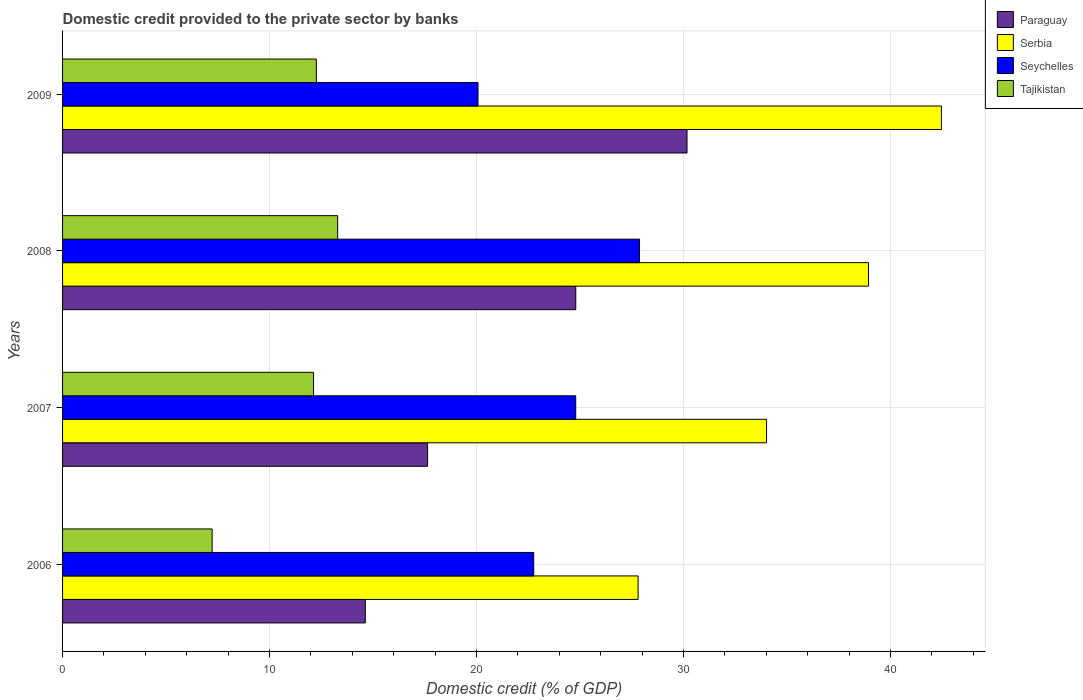How many different coloured bars are there?
Provide a succinct answer. 4. Are the number of bars per tick equal to the number of legend labels?
Give a very brief answer. Yes. How many bars are there on the 2nd tick from the bottom?
Provide a short and direct response. 4. In how many cases, is the number of bars for a given year not equal to the number of legend labels?
Keep it short and to the point. 0. What is the domestic credit provided to the private sector by banks in Tajikistan in 2009?
Keep it short and to the point. 12.26. Across all years, what is the maximum domestic credit provided to the private sector by banks in Serbia?
Your response must be concise. 42.46. Across all years, what is the minimum domestic credit provided to the private sector by banks in Seychelles?
Provide a short and direct response. 20.07. In which year was the domestic credit provided to the private sector by banks in Serbia minimum?
Keep it short and to the point. 2006. What is the total domestic credit provided to the private sector by banks in Serbia in the graph?
Your response must be concise. 143.23. What is the difference between the domestic credit provided to the private sector by banks in Serbia in 2008 and that in 2009?
Offer a very short reply. -3.52. What is the difference between the domestic credit provided to the private sector by banks in Paraguay in 2009 and the domestic credit provided to the private sector by banks in Seychelles in 2007?
Offer a very short reply. 5.38. What is the average domestic credit provided to the private sector by banks in Serbia per year?
Your response must be concise. 35.81. In the year 2008, what is the difference between the domestic credit provided to the private sector by banks in Seychelles and domestic credit provided to the private sector by banks in Serbia?
Provide a short and direct response. -11.06. What is the ratio of the domestic credit provided to the private sector by banks in Tajikistan in 2006 to that in 2009?
Your response must be concise. 0.59. Is the domestic credit provided to the private sector by banks in Serbia in 2007 less than that in 2008?
Offer a very short reply. Yes. Is the difference between the domestic credit provided to the private sector by banks in Seychelles in 2006 and 2008 greater than the difference between the domestic credit provided to the private sector by banks in Serbia in 2006 and 2008?
Your answer should be compact. Yes. What is the difference between the highest and the second highest domestic credit provided to the private sector by banks in Tajikistan?
Your answer should be very brief. 1.03. What is the difference between the highest and the lowest domestic credit provided to the private sector by banks in Paraguay?
Make the answer very short. 15.54. In how many years, is the domestic credit provided to the private sector by banks in Tajikistan greater than the average domestic credit provided to the private sector by banks in Tajikistan taken over all years?
Provide a succinct answer. 3. What does the 1st bar from the top in 2008 represents?
Your answer should be compact. Tajikistan. What does the 1st bar from the bottom in 2006 represents?
Provide a short and direct response. Paraguay. How many bars are there?
Give a very brief answer. 16. How many years are there in the graph?
Provide a succinct answer. 4. Does the graph contain any zero values?
Provide a short and direct response. No. Does the graph contain grids?
Provide a short and direct response. Yes. Where does the legend appear in the graph?
Offer a terse response. Top right. How many legend labels are there?
Provide a succinct answer. 4. How are the legend labels stacked?
Your response must be concise. Vertical. What is the title of the graph?
Your answer should be compact. Domestic credit provided to the private sector by banks. What is the label or title of the X-axis?
Provide a succinct answer. Domestic credit (% of GDP). What is the Domestic credit (% of GDP) in Paraguay in 2006?
Offer a terse response. 14.63. What is the Domestic credit (% of GDP) in Serbia in 2006?
Keep it short and to the point. 27.81. What is the Domestic credit (% of GDP) in Seychelles in 2006?
Offer a very short reply. 22.76. What is the Domestic credit (% of GDP) of Tajikistan in 2006?
Provide a succinct answer. 7.23. What is the Domestic credit (% of GDP) of Paraguay in 2007?
Your answer should be compact. 17.64. What is the Domestic credit (% of GDP) of Serbia in 2007?
Offer a very short reply. 34.01. What is the Domestic credit (% of GDP) in Seychelles in 2007?
Ensure brevity in your answer.  24.79. What is the Domestic credit (% of GDP) in Tajikistan in 2007?
Give a very brief answer. 12.13. What is the Domestic credit (% of GDP) in Paraguay in 2008?
Your answer should be compact. 24.8. What is the Domestic credit (% of GDP) in Serbia in 2008?
Offer a very short reply. 38.94. What is the Domestic credit (% of GDP) in Seychelles in 2008?
Offer a very short reply. 27.88. What is the Domestic credit (% of GDP) of Tajikistan in 2008?
Your answer should be very brief. 13.29. What is the Domestic credit (% of GDP) in Paraguay in 2009?
Ensure brevity in your answer.  30.17. What is the Domestic credit (% of GDP) in Serbia in 2009?
Offer a very short reply. 42.46. What is the Domestic credit (% of GDP) in Seychelles in 2009?
Your answer should be very brief. 20.07. What is the Domestic credit (% of GDP) of Tajikistan in 2009?
Offer a terse response. 12.26. Across all years, what is the maximum Domestic credit (% of GDP) in Paraguay?
Offer a very short reply. 30.17. Across all years, what is the maximum Domestic credit (% of GDP) of Serbia?
Your response must be concise. 42.46. Across all years, what is the maximum Domestic credit (% of GDP) in Seychelles?
Ensure brevity in your answer.  27.88. Across all years, what is the maximum Domestic credit (% of GDP) of Tajikistan?
Offer a terse response. 13.29. Across all years, what is the minimum Domestic credit (% of GDP) in Paraguay?
Make the answer very short. 14.63. Across all years, what is the minimum Domestic credit (% of GDP) in Serbia?
Provide a succinct answer. 27.81. Across all years, what is the minimum Domestic credit (% of GDP) of Seychelles?
Your response must be concise. 20.07. Across all years, what is the minimum Domestic credit (% of GDP) in Tajikistan?
Offer a terse response. 7.23. What is the total Domestic credit (% of GDP) in Paraguay in the graph?
Provide a short and direct response. 87.23. What is the total Domestic credit (% of GDP) of Serbia in the graph?
Give a very brief answer. 143.23. What is the total Domestic credit (% of GDP) in Seychelles in the graph?
Make the answer very short. 95.51. What is the total Domestic credit (% of GDP) of Tajikistan in the graph?
Ensure brevity in your answer.  44.91. What is the difference between the Domestic credit (% of GDP) of Paraguay in 2006 and that in 2007?
Make the answer very short. -3.01. What is the difference between the Domestic credit (% of GDP) in Serbia in 2006 and that in 2007?
Offer a very short reply. -6.21. What is the difference between the Domestic credit (% of GDP) of Seychelles in 2006 and that in 2007?
Your answer should be compact. -2.03. What is the difference between the Domestic credit (% of GDP) in Tajikistan in 2006 and that in 2007?
Your answer should be very brief. -4.9. What is the difference between the Domestic credit (% of GDP) in Paraguay in 2006 and that in 2008?
Ensure brevity in your answer.  -10.17. What is the difference between the Domestic credit (% of GDP) in Serbia in 2006 and that in 2008?
Your response must be concise. -11.13. What is the difference between the Domestic credit (% of GDP) in Seychelles in 2006 and that in 2008?
Make the answer very short. -5.11. What is the difference between the Domestic credit (% of GDP) in Tajikistan in 2006 and that in 2008?
Make the answer very short. -6.07. What is the difference between the Domestic credit (% of GDP) in Paraguay in 2006 and that in 2009?
Your answer should be very brief. -15.54. What is the difference between the Domestic credit (% of GDP) of Serbia in 2006 and that in 2009?
Provide a short and direct response. -14.66. What is the difference between the Domestic credit (% of GDP) in Seychelles in 2006 and that in 2009?
Make the answer very short. 2.69. What is the difference between the Domestic credit (% of GDP) of Tajikistan in 2006 and that in 2009?
Ensure brevity in your answer.  -5.04. What is the difference between the Domestic credit (% of GDP) of Paraguay in 2007 and that in 2008?
Offer a very short reply. -7.16. What is the difference between the Domestic credit (% of GDP) in Serbia in 2007 and that in 2008?
Provide a short and direct response. -4.93. What is the difference between the Domestic credit (% of GDP) in Seychelles in 2007 and that in 2008?
Give a very brief answer. -3.08. What is the difference between the Domestic credit (% of GDP) in Tajikistan in 2007 and that in 2008?
Your answer should be compact. -1.17. What is the difference between the Domestic credit (% of GDP) in Paraguay in 2007 and that in 2009?
Your answer should be very brief. -12.54. What is the difference between the Domestic credit (% of GDP) in Serbia in 2007 and that in 2009?
Your response must be concise. -8.45. What is the difference between the Domestic credit (% of GDP) in Seychelles in 2007 and that in 2009?
Provide a short and direct response. 4.72. What is the difference between the Domestic credit (% of GDP) of Tajikistan in 2007 and that in 2009?
Offer a very short reply. -0.14. What is the difference between the Domestic credit (% of GDP) of Paraguay in 2008 and that in 2009?
Keep it short and to the point. -5.38. What is the difference between the Domestic credit (% of GDP) in Serbia in 2008 and that in 2009?
Keep it short and to the point. -3.52. What is the difference between the Domestic credit (% of GDP) in Seychelles in 2008 and that in 2009?
Your answer should be very brief. 7.8. What is the difference between the Domestic credit (% of GDP) of Tajikistan in 2008 and that in 2009?
Your answer should be compact. 1.03. What is the difference between the Domestic credit (% of GDP) in Paraguay in 2006 and the Domestic credit (% of GDP) in Serbia in 2007?
Your answer should be compact. -19.39. What is the difference between the Domestic credit (% of GDP) in Paraguay in 2006 and the Domestic credit (% of GDP) in Seychelles in 2007?
Your response must be concise. -10.17. What is the difference between the Domestic credit (% of GDP) in Paraguay in 2006 and the Domestic credit (% of GDP) in Tajikistan in 2007?
Give a very brief answer. 2.5. What is the difference between the Domestic credit (% of GDP) of Serbia in 2006 and the Domestic credit (% of GDP) of Seychelles in 2007?
Provide a succinct answer. 3.01. What is the difference between the Domestic credit (% of GDP) of Serbia in 2006 and the Domestic credit (% of GDP) of Tajikistan in 2007?
Offer a very short reply. 15.68. What is the difference between the Domestic credit (% of GDP) in Seychelles in 2006 and the Domestic credit (% of GDP) in Tajikistan in 2007?
Give a very brief answer. 10.64. What is the difference between the Domestic credit (% of GDP) in Paraguay in 2006 and the Domestic credit (% of GDP) in Serbia in 2008?
Ensure brevity in your answer.  -24.31. What is the difference between the Domestic credit (% of GDP) of Paraguay in 2006 and the Domestic credit (% of GDP) of Seychelles in 2008?
Offer a very short reply. -13.25. What is the difference between the Domestic credit (% of GDP) of Paraguay in 2006 and the Domestic credit (% of GDP) of Tajikistan in 2008?
Offer a very short reply. 1.33. What is the difference between the Domestic credit (% of GDP) in Serbia in 2006 and the Domestic credit (% of GDP) in Seychelles in 2008?
Ensure brevity in your answer.  -0.07. What is the difference between the Domestic credit (% of GDP) of Serbia in 2006 and the Domestic credit (% of GDP) of Tajikistan in 2008?
Keep it short and to the point. 14.52. What is the difference between the Domestic credit (% of GDP) of Seychelles in 2006 and the Domestic credit (% of GDP) of Tajikistan in 2008?
Offer a terse response. 9.47. What is the difference between the Domestic credit (% of GDP) in Paraguay in 2006 and the Domestic credit (% of GDP) in Serbia in 2009?
Offer a terse response. -27.84. What is the difference between the Domestic credit (% of GDP) in Paraguay in 2006 and the Domestic credit (% of GDP) in Seychelles in 2009?
Give a very brief answer. -5.45. What is the difference between the Domestic credit (% of GDP) of Paraguay in 2006 and the Domestic credit (% of GDP) of Tajikistan in 2009?
Keep it short and to the point. 2.36. What is the difference between the Domestic credit (% of GDP) of Serbia in 2006 and the Domestic credit (% of GDP) of Seychelles in 2009?
Offer a terse response. 7.73. What is the difference between the Domestic credit (% of GDP) in Serbia in 2006 and the Domestic credit (% of GDP) in Tajikistan in 2009?
Your response must be concise. 15.55. What is the difference between the Domestic credit (% of GDP) in Seychelles in 2006 and the Domestic credit (% of GDP) in Tajikistan in 2009?
Ensure brevity in your answer.  10.5. What is the difference between the Domestic credit (% of GDP) of Paraguay in 2007 and the Domestic credit (% of GDP) of Serbia in 2008?
Provide a succinct answer. -21.3. What is the difference between the Domestic credit (% of GDP) in Paraguay in 2007 and the Domestic credit (% of GDP) in Seychelles in 2008?
Your response must be concise. -10.24. What is the difference between the Domestic credit (% of GDP) in Paraguay in 2007 and the Domestic credit (% of GDP) in Tajikistan in 2008?
Offer a terse response. 4.34. What is the difference between the Domestic credit (% of GDP) in Serbia in 2007 and the Domestic credit (% of GDP) in Seychelles in 2008?
Give a very brief answer. 6.14. What is the difference between the Domestic credit (% of GDP) in Serbia in 2007 and the Domestic credit (% of GDP) in Tajikistan in 2008?
Provide a short and direct response. 20.72. What is the difference between the Domestic credit (% of GDP) in Seychelles in 2007 and the Domestic credit (% of GDP) in Tajikistan in 2008?
Your answer should be compact. 11.5. What is the difference between the Domestic credit (% of GDP) of Paraguay in 2007 and the Domestic credit (% of GDP) of Serbia in 2009?
Provide a succinct answer. -24.83. What is the difference between the Domestic credit (% of GDP) in Paraguay in 2007 and the Domestic credit (% of GDP) in Seychelles in 2009?
Give a very brief answer. -2.44. What is the difference between the Domestic credit (% of GDP) in Paraguay in 2007 and the Domestic credit (% of GDP) in Tajikistan in 2009?
Make the answer very short. 5.37. What is the difference between the Domestic credit (% of GDP) in Serbia in 2007 and the Domestic credit (% of GDP) in Seychelles in 2009?
Your answer should be very brief. 13.94. What is the difference between the Domestic credit (% of GDP) in Serbia in 2007 and the Domestic credit (% of GDP) in Tajikistan in 2009?
Give a very brief answer. 21.75. What is the difference between the Domestic credit (% of GDP) of Seychelles in 2007 and the Domestic credit (% of GDP) of Tajikistan in 2009?
Keep it short and to the point. 12.53. What is the difference between the Domestic credit (% of GDP) of Paraguay in 2008 and the Domestic credit (% of GDP) of Serbia in 2009?
Give a very brief answer. -17.67. What is the difference between the Domestic credit (% of GDP) in Paraguay in 2008 and the Domestic credit (% of GDP) in Seychelles in 2009?
Provide a short and direct response. 4.72. What is the difference between the Domestic credit (% of GDP) of Paraguay in 2008 and the Domestic credit (% of GDP) of Tajikistan in 2009?
Ensure brevity in your answer.  12.53. What is the difference between the Domestic credit (% of GDP) in Serbia in 2008 and the Domestic credit (% of GDP) in Seychelles in 2009?
Provide a succinct answer. 18.87. What is the difference between the Domestic credit (% of GDP) of Serbia in 2008 and the Domestic credit (% of GDP) of Tajikistan in 2009?
Offer a terse response. 26.68. What is the difference between the Domestic credit (% of GDP) in Seychelles in 2008 and the Domestic credit (% of GDP) in Tajikistan in 2009?
Give a very brief answer. 15.61. What is the average Domestic credit (% of GDP) of Paraguay per year?
Keep it short and to the point. 21.81. What is the average Domestic credit (% of GDP) of Serbia per year?
Ensure brevity in your answer.  35.81. What is the average Domestic credit (% of GDP) in Seychelles per year?
Ensure brevity in your answer.  23.88. What is the average Domestic credit (% of GDP) of Tajikistan per year?
Keep it short and to the point. 11.23. In the year 2006, what is the difference between the Domestic credit (% of GDP) in Paraguay and Domestic credit (% of GDP) in Serbia?
Ensure brevity in your answer.  -13.18. In the year 2006, what is the difference between the Domestic credit (% of GDP) of Paraguay and Domestic credit (% of GDP) of Seychelles?
Make the answer very short. -8.14. In the year 2006, what is the difference between the Domestic credit (% of GDP) in Paraguay and Domestic credit (% of GDP) in Tajikistan?
Your response must be concise. 7.4. In the year 2006, what is the difference between the Domestic credit (% of GDP) in Serbia and Domestic credit (% of GDP) in Seychelles?
Your response must be concise. 5.04. In the year 2006, what is the difference between the Domestic credit (% of GDP) of Serbia and Domestic credit (% of GDP) of Tajikistan?
Your answer should be very brief. 20.58. In the year 2006, what is the difference between the Domestic credit (% of GDP) of Seychelles and Domestic credit (% of GDP) of Tajikistan?
Your answer should be very brief. 15.54. In the year 2007, what is the difference between the Domestic credit (% of GDP) of Paraguay and Domestic credit (% of GDP) of Serbia?
Make the answer very short. -16.38. In the year 2007, what is the difference between the Domestic credit (% of GDP) in Paraguay and Domestic credit (% of GDP) in Seychelles?
Provide a short and direct response. -7.16. In the year 2007, what is the difference between the Domestic credit (% of GDP) of Paraguay and Domestic credit (% of GDP) of Tajikistan?
Offer a terse response. 5.51. In the year 2007, what is the difference between the Domestic credit (% of GDP) of Serbia and Domestic credit (% of GDP) of Seychelles?
Make the answer very short. 9.22. In the year 2007, what is the difference between the Domestic credit (% of GDP) in Serbia and Domestic credit (% of GDP) in Tajikistan?
Keep it short and to the point. 21.89. In the year 2007, what is the difference between the Domestic credit (% of GDP) in Seychelles and Domestic credit (% of GDP) in Tajikistan?
Provide a short and direct response. 12.67. In the year 2008, what is the difference between the Domestic credit (% of GDP) of Paraguay and Domestic credit (% of GDP) of Serbia?
Ensure brevity in your answer.  -14.14. In the year 2008, what is the difference between the Domestic credit (% of GDP) of Paraguay and Domestic credit (% of GDP) of Seychelles?
Keep it short and to the point. -3.08. In the year 2008, what is the difference between the Domestic credit (% of GDP) in Paraguay and Domestic credit (% of GDP) in Tajikistan?
Give a very brief answer. 11.5. In the year 2008, what is the difference between the Domestic credit (% of GDP) in Serbia and Domestic credit (% of GDP) in Seychelles?
Ensure brevity in your answer.  11.06. In the year 2008, what is the difference between the Domestic credit (% of GDP) of Serbia and Domestic credit (% of GDP) of Tajikistan?
Provide a short and direct response. 25.65. In the year 2008, what is the difference between the Domestic credit (% of GDP) in Seychelles and Domestic credit (% of GDP) in Tajikistan?
Provide a succinct answer. 14.58. In the year 2009, what is the difference between the Domestic credit (% of GDP) in Paraguay and Domestic credit (% of GDP) in Serbia?
Provide a succinct answer. -12.29. In the year 2009, what is the difference between the Domestic credit (% of GDP) of Paraguay and Domestic credit (% of GDP) of Seychelles?
Your answer should be compact. 10.1. In the year 2009, what is the difference between the Domestic credit (% of GDP) of Paraguay and Domestic credit (% of GDP) of Tajikistan?
Ensure brevity in your answer.  17.91. In the year 2009, what is the difference between the Domestic credit (% of GDP) of Serbia and Domestic credit (% of GDP) of Seychelles?
Offer a terse response. 22.39. In the year 2009, what is the difference between the Domestic credit (% of GDP) in Serbia and Domestic credit (% of GDP) in Tajikistan?
Provide a short and direct response. 30.2. In the year 2009, what is the difference between the Domestic credit (% of GDP) of Seychelles and Domestic credit (% of GDP) of Tajikistan?
Give a very brief answer. 7.81. What is the ratio of the Domestic credit (% of GDP) of Paraguay in 2006 to that in 2007?
Your answer should be compact. 0.83. What is the ratio of the Domestic credit (% of GDP) in Serbia in 2006 to that in 2007?
Ensure brevity in your answer.  0.82. What is the ratio of the Domestic credit (% of GDP) of Seychelles in 2006 to that in 2007?
Ensure brevity in your answer.  0.92. What is the ratio of the Domestic credit (% of GDP) in Tajikistan in 2006 to that in 2007?
Give a very brief answer. 0.6. What is the ratio of the Domestic credit (% of GDP) in Paraguay in 2006 to that in 2008?
Ensure brevity in your answer.  0.59. What is the ratio of the Domestic credit (% of GDP) of Serbia in 2006 to that in 2008?
Provide a short and direct response. 0.71. What is the ratio of the Domestic credit (% of GDP) of Seychelles in 2006 to that in 2008?
Your answer should be compact. 0.82. What is the ratio of the Domestic credit (% of GDP) in Tajikistan in 2006 to that in 2008?
Keep it short and to the point. 0.54. What is the ratio of the Domestic credit (% of GDP) in Paraguay in 2006 to that in 2009?
Provide a short and direct response. 0.48. What is the ratio of the Domestic credit (% of GDP) of Serbia in 2006 to that in 2009?
Make the answer very short. 0.65. What is the ratio of the Domestic credit (% of GDP) of Seychelles in 2006 to that in 2009?
Give a very brief answer. 1.13. What is the ratio of the Domestic credit (% of GDP) of Tajikistan in 2006 to that in 2009?
Provide a succinct answer. 0.59. What is the ratio of the Domestic credit (% of GDP) of Paraguay in 2007 to that in 2008?
Make the answer very short. 0.71. What is the ratio of the Domestic credit (% of GDP) of Serbia in 2007 to that in 2008?
Your response must be concise. 0.87. What is the ratio of the Domestic credit (% of GDP) of Seychelles in 2007 to that in 2008?
Your answer should be compact. 0.89. What is the ratio of the Domestic credit (% of GDP) in Tajikistan in 2007 to that in 2008?
Provide a short and direct response. 0.91. What is the ratio of the Domestic credit (% of GDP) in Paraguay in 2007 to that in 2009?
Give a very brief answer. 0.58. What is the ratio of the Domestic credit (% of GDP) of Serbia in 2007 to that in 2009?
Keep it short and to the point. 0.8. What is the ratio of the Domestic credit (% of GDP) in Seychelles in 2007 to that in 2009?
Make the answer very short. 1.24. What is the ratio of the Domestic credit (% of GDP) of Tajikistan in 2007 to that in 2009?
Keep it short and to the point. 0.99. What is the ratio of the Domestic credit (% of GDP) of Paraguay in 2008 to that in 2009?
Offer a very short reply. 0.82. What is the ratio of the Domestic credit (% of GDP) in Serbia in 2008 to that in 2009?
Keep it short and to the point. 0.92. What is the ratio of the Domestic credit (% of GDP) in Seychelles in 2008 to that in 2009?
Your answer should be compact. 1.39. What is the ratio of the Domestic credit (% of GDP) of Tajikistan in 2008 to that in 2009?
Provide a succinct answer. 1.08. What is the difference between the highest and the second highest Domestic credit (% of GDP) of Paraguay?
Provide a succinct answer. 5.38. What is the difference between the highest and the second highest Domestic credit (% of GDP) in Serbia?
Give a very brief answer. 3.52. What is the difference between the highest and the second highest Domestic credit (% of GDP) of Seychelles?
Give a very brief answer. 3.08. What is the difference between the highest and the second highest Domestic credit (% of GDP) of Tajikistan?
Your answer should be very brief. 1.03. What is the difference between the highest and the lowest Domestic credit (% of GDP) in Paraguay?
Give a very brief answer. 15.54. What is the difference between the highest and the lowest Domestic credit (% of GDP) of Serbia?
Provide a short and direct response. 14.66. What is the difference between the highest and the lowest Domestic credit (% of GDP) in Seychelles?
Ensure brevity in your answer.  7.8. What is the difference between the highest and the lowest Domestic credit (% of GDP) in Tajikistan?
Your response must be concise. 6.07. 